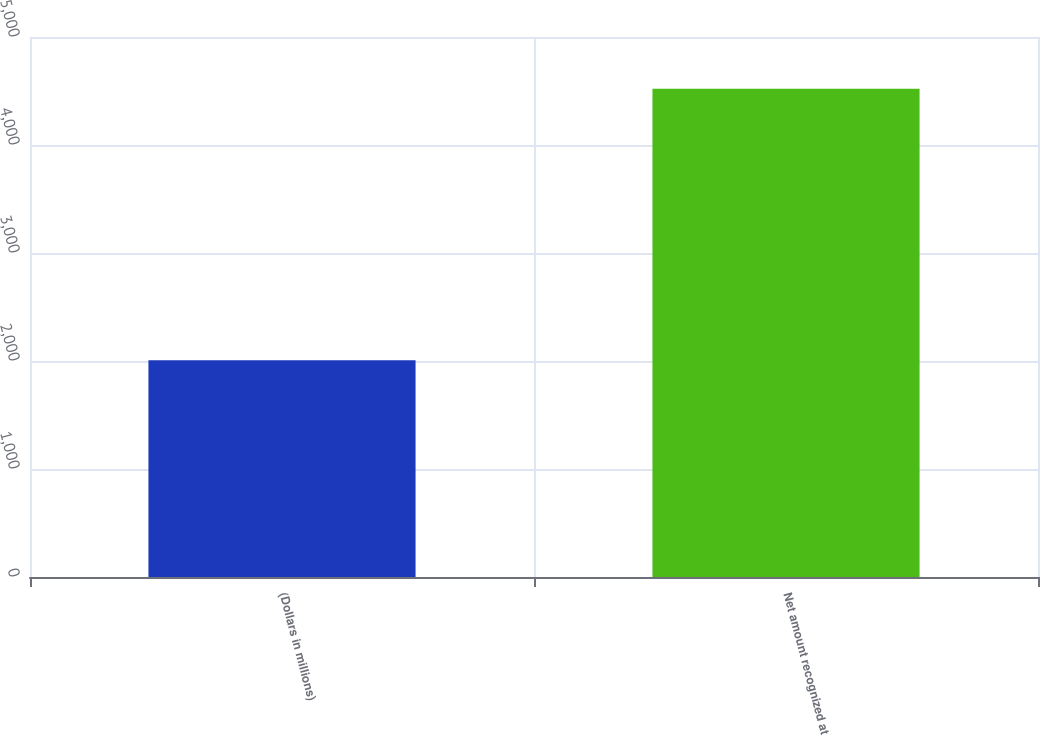Convert chart. <chart><loc_0><loc_0><loc_500><loc_500><bar_chart><fcel>(Dollars in millions)<fcel>Net amount recognized at<nl><fcel>2007<fcel>4520<nl></chart> 